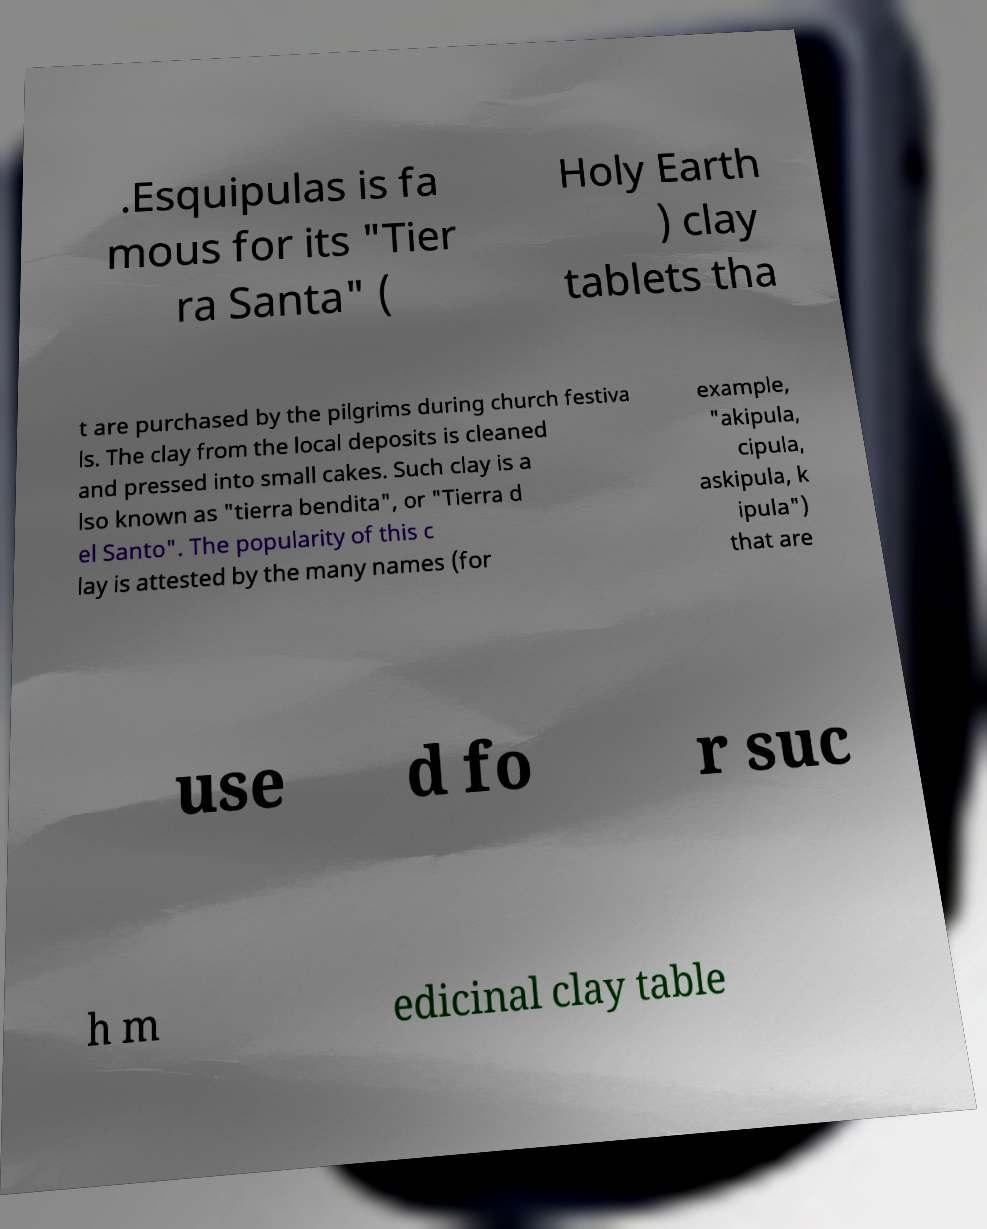There's text embedded in this image that I need extracted. Can you transcribe it verbatim? .Esquipulas is fa mous for its "Tier ra Santa" ( Holy Earth ) clay tablets tha t are purchased by the pilgrims during church festiva ls. The clay from the local deposits is cleaned and pressed into small cakes. Such clay is a lso known as "tierra bendita", or "Tierra d el Santo". The popularity of this c lay is attested by the many names (for example, "akipula, cipula, askipula, k ipula") that are use d fo r suc h m edicinal clay table 